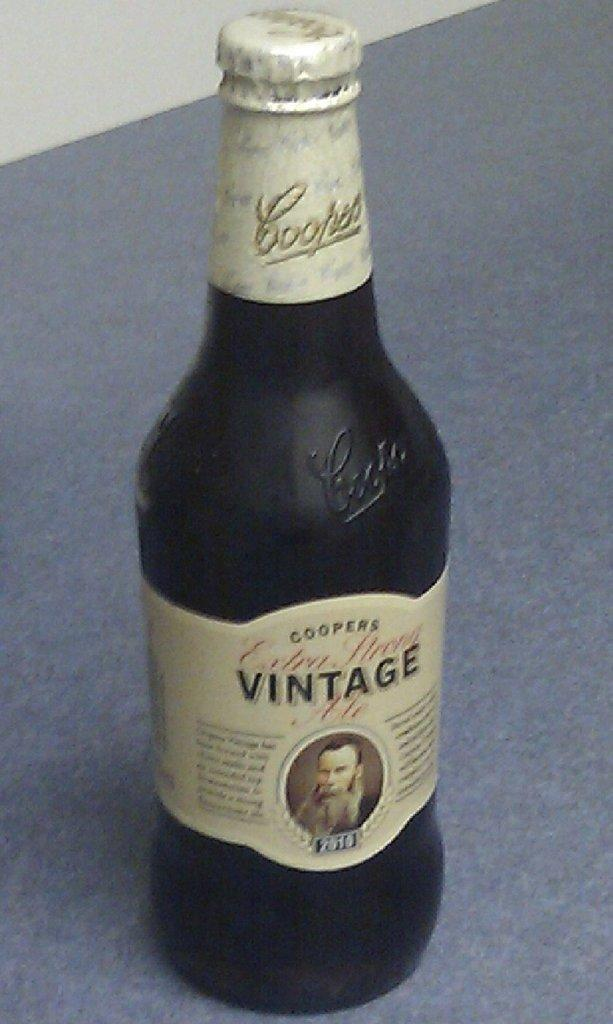Provide a one-sentence caption for the provided image. a Vintage bottle with a man's face on it. 